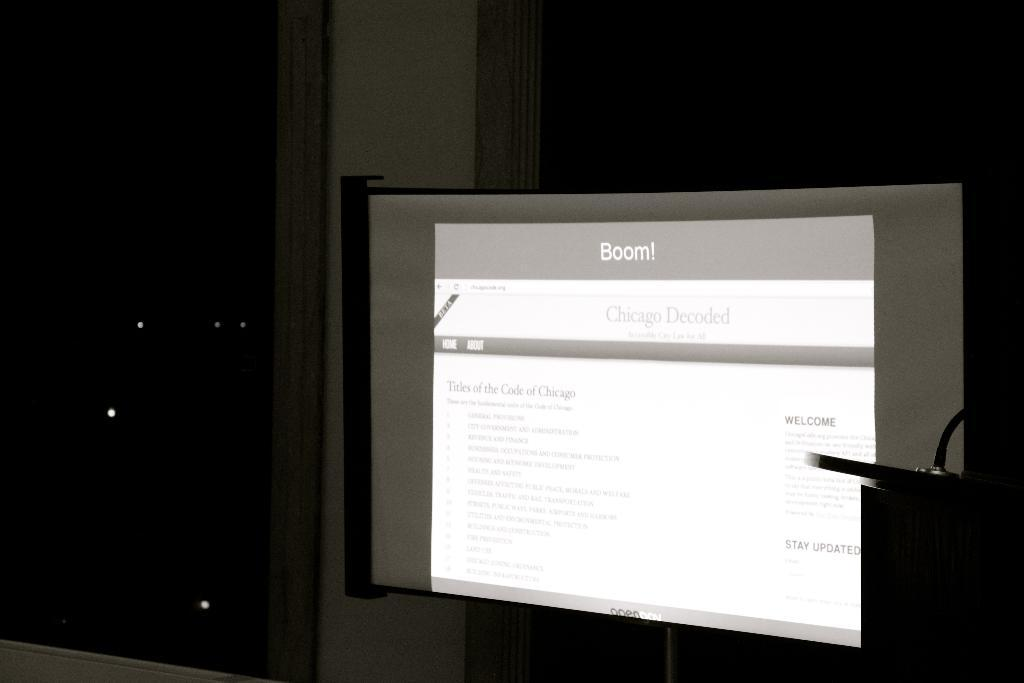<image>
Describe the image concisely. A picture of a computer monitor with a "Chicago Decoded" blog shown on it 